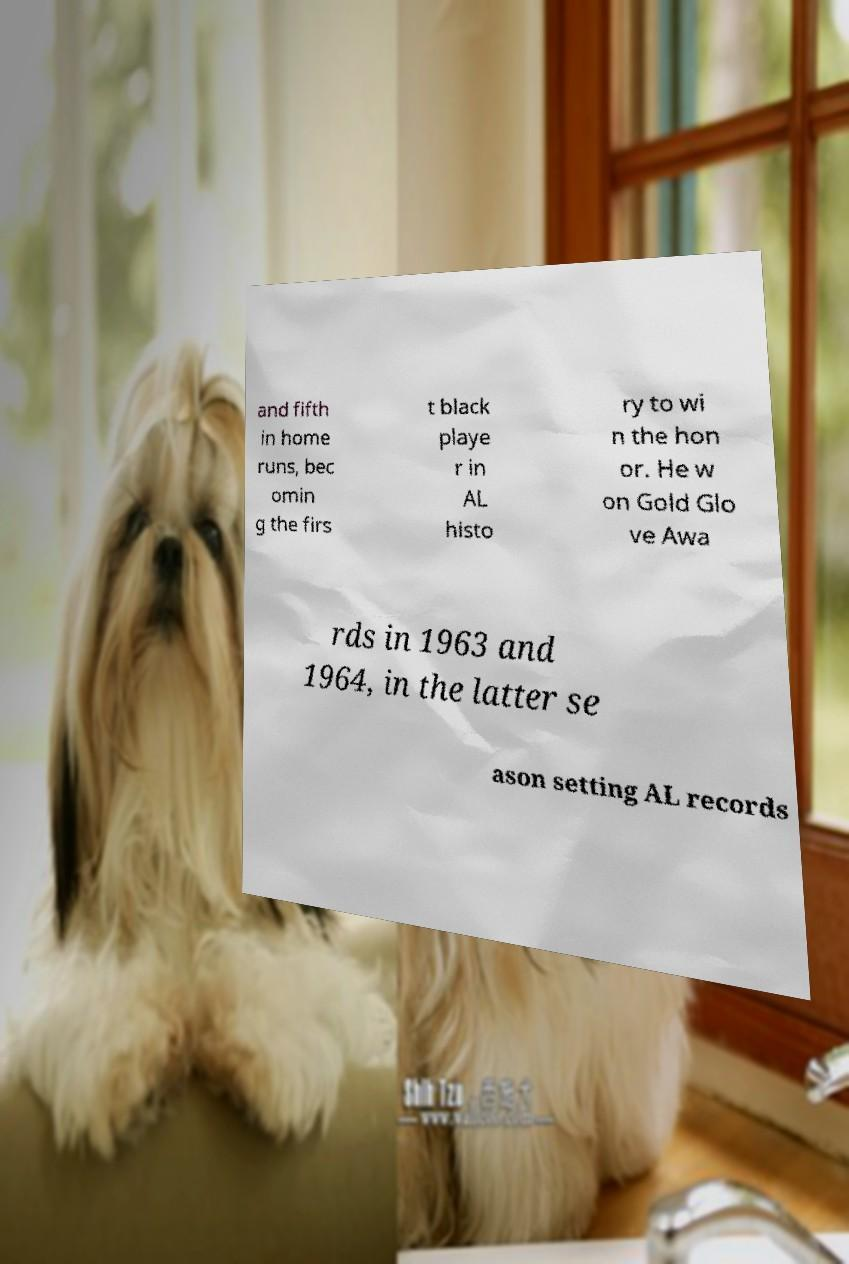Can you accurately transcribe the text from the provided image for me? and fifth in home runs, bec omin g the firs t black playe r in AL histo ry to wi n the hon or. He w on Gold Glo ve Awa rds in 1963 and 1964, in the latter se ason setting AL records 